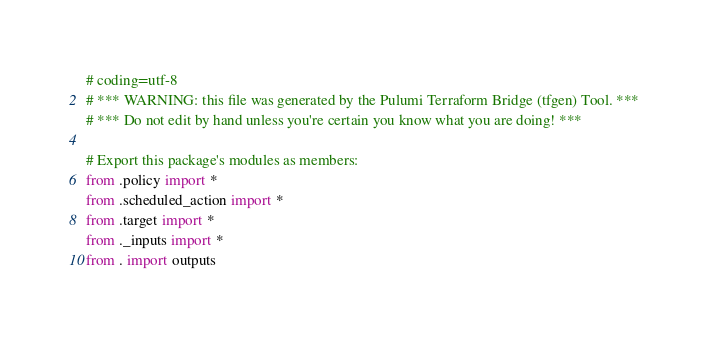<code> <loc_0><loc_0><loc_500><loc_500><_Python_># coding=utf-8
# *** WARNING: this file was generated by the Pulumi Terraform Bridge (tfgen) Tool. ***
# *** Do not edit by hand unless you're certain you know what you are doing! ***

# Export this package's modules as members:
from .policy import *
from .scheduled_action import *
from .target import *
from ._inputs import *
from . import outputs
</code> 